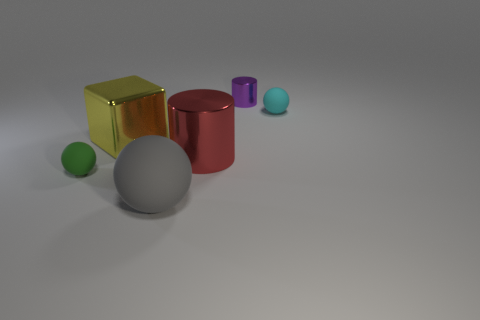Add 2 cubes. How many objects exist? 8 Subtract all cubes. How many objects are left? 5 Add 4 metal cylinders. How many metal cylinders exist? 6 Subtract 0 cyan cylinders. How many objects are left? 6 Subtract all small red metallic balls. Subtract all green rubber objects. How many objects are left? 5 Add 5 big metal objects. How many big metal objects are left? 7 